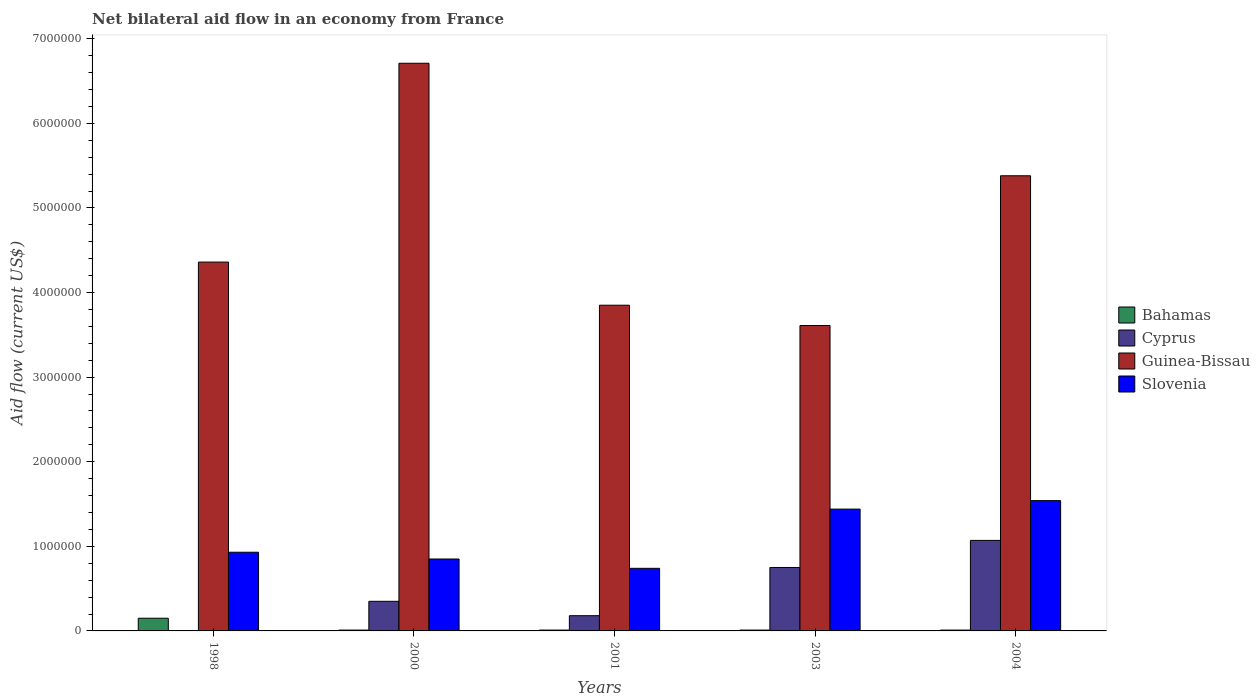How many different coloured bars are there?
Your answer should be very brief. 4. Are the number of bars per tick equal to the number of legend labels?
Provide a short and direct response. No. How many bars are there on the 3rd tick from the right?
Your response must be concise. 4. In how many cases, is the number of bars for a given year not equal to the number of legend labels?
Offer a very short reply. 1. What is the net bilateral aid flow in Slovenia in 2000?
Make the answer very short. 8.50e+05. Across all years, what is the maximum net bilateral aid flow in Cyprus?
Make the answer very short. 1.07e+06. What is the total net bilateral aid flow in Slovenia in the graph?
Make the answer very short. 5.50e+06. What is the difference between the net bilateral aid flow in Slovenia in 2000 and that in 2004?
Your response must be concise. -6.90e+05. What is the difference between the net bilateral aid flow in Cyprus in 2000 and the net bilateral aid flow in Guinea-Bissau in 1998?
Offer a terse response. -4.01e+06. What is the average net bilateral aid flow in Slovenia per year?
Give a very brief answer. 1.10e+06. In the year 2001, what is the difference between the net bilateral aid flow in Cyprus and net bilateral aid flow in Slovenia?
Make the answer very short. -5.60e+05. In how many years, is the net bilateral aid flow in Guinea-Bissau greater than 5800000 US$?
Make the answer very short. 1. What is the ratio of the net bilateral aid flow in Guinea-Bissau in 1998 to that in 2001?
Provide a succinct answer. 1.13. What is the difference between the highest and the second highest net bilateral aid flow in Cyprus?
Your answer should be very brief. 3.20e+05. What is the difference between the highest and the lowest net bilateral aid flow in Cyprus?
Keep it short and to the point. 1.07e+06. In how many years, is the net bilateral aid flow in Bahamas greater than the average net bilateral aid flow in Bahamas taken over all years?
Provide a short and direct response. 1. Is it the case that in every year, the sum of the net bilateral aid flow in Cyprus and net bilateral aid flow in Guinea-Bissau is greater than the sum of net bilateral aid flow in Slovenia and net bilateral aid flow in Bahamas?
Make the answer very short. Yes. Is it the case that in every year, the sum of the net bilateral aid flow in Slovenia and net bilateral aid flow in Guinea-Bissau is greater than the net bilateral aid flow in Cyprus?
Keep it short and to the point. Yes. Are all the bars in the graph horizontal?
Offer a very short reply. No. Does the graph contain any zero values?
Keep it short and to the point. Yes. Does the graph contain grids?
Offer a terse response. No. Where does the legend appear in the graph?
Your answer should be very brief. Center right. How many legend labels are there?
Give a very brief answer. 4. What is the title of the graph?
Your answer should be compact. Net bilateral aid flow in an economy from France. Does "Cuba" appear as one of the legend labels in the graph?
Your response must be concise. No. What is the label or title of the Y-axis?
Give a very brief answer. Aid flow (current US$). What is the Aid flow (current US$) in Bahamas in 1998?
Offer a very short reply. 1.50e+05. What is the Aid flow (current US$) of Cyprus in 1998?
Your answer should be compact. 0. What is the Aid flow (current US$) of Guinea-Bissau in 1998?
Offer a very short reply. 4.36e+06. What is the Aid flow (current US$) in Slovenia in 1998?
Make the answer very short. 9.30e+05. What is the Aid flow (current US$) of Bahamas in 2000?
Provide a succinct answer. 10000. What is the Aid flow (current US$) in Guinea-Bissau in 2000?
Offer a terse response. 6.71e+06. What is the Aid flow (current US$) of Slovenia in 2000?
Make the answer very short. 8.50e+05. What is the Aid flow (current US$) in Bahamas in 2001?
Keep it short and to the point. 10000. What is the Aid flow (current US$) in Cyprus in 2001?
Your answer should be compact. 1.80e+05. What is the Aid flow (current US$) of Guinea-Bissau in 2001?
Keep it short and to the point. 3.85e+06. What is the Aid flow (current US$) in Slovenia in 2001?
Offer a very short reply. 7.40e+05. What is the Aid flow (current US$) of Cyprus in 2003?
Keep it short and to the point. 7.50e+05. What is the Aid flow (current US$) in Guinea-Bissau in 2003?
Ensure brevity in your answer.  3.61e+06. What is the Aid flow (current US$) of Slovenia in 2003?
Provide a short and direct response. 1.44e+06. What is the Aid flow (current US$) in Cyprus in 2004?
Your response must be concise. 1.07e+06. What is the Aid flow (current US$) in Guinea-Bissau in 2004?
Make the answer very short. 5.38e+06. What is the Aid flow (current US$) in Slovenia in 2004?
Provide a short and direct response. 1.54e+06. Across all years, what is the maximum Aid flow (current US$) in Cyprus?
Make the answer very short. 1.07e+06. Across all years, what is the maximum Aid flow (current US$) of Guinea-Bissau?
Ensure brevity in your answer.  6.71e+06. Across all years, what is the maximum Aid flow (current US$) of Slovenia?
Your answer should be very brief. 1.54e+06. Across all years, what is the minimum Aid flow (current US$) in Cyprus?
Ensure brevity in your answer.  0. Across all years, what is the minimum Aid flow (current US$) of Guinea-Bissau?
Provide a short and direct response. 3.61e+06. Across all years, what is the minimum Aid flow (current US$) of Slovenia?
Your answer should be compact. 7.40e+05. What is the total Aid flow (current US$) of Cyprus in the graph?
Provide a succinct answer. 2.35e+06. What is the total Aid flow (current US$) in Guinea-Bissau in the graph?
Your answer should be compact. 2.39e+07. What is the total Aid flow (current US$) of Slovenia in the graph?
Offer a very short reply. 5.50e+06. What is the difference between the Aid flow (current US$) of Guinea-Bissau in 1998 and that in 2000?
Keep it short and to the point. -2.35e+06. What is the difference between the Aid flow (current US$) in Guinea-Bissau in 1998 and that in 2001?
Offer a very short reply. 5.10e+05. What is the difference between the Aid flow (current US$) of Guinea-Bissau in 1998 and that in 2003?
Provide a short and direct response. 7.50e+05. What is the difference between the Aid flow (current US$) in Slovenia in 1998 and that in 2003?
Keep it short and to the point. -5.10e+05. What is the difference between the Aid flow (current US$) in Guinea-Bissau in 1998 and that in 2004?
Give a very brief answer. -1.02e+06. What is the difference between the Aid flow (current US$) of Slovenia in 1998 and that in 2004?
Keep it short and to the point. -6.10e+05. What is the difference between the Aid flow (current US$) of Bahamas in 2000 and that in 2001?
Provide a succinct answer. 0. What is the difference between the Aid flow (current US$) of Guinea-Bissau in 2000 and that in 2001?
Make the answer very short. 2.86e+06. What is the difference between the Aid flow (current US$) in Bahamas in 2000 and that in 2003?
Provide a short and direct response. 0. What is the difference between the Aid flow (current US$) of Cyprus in 2000 and that in 2003?
Your response must be concise. -4.00e+05. What is the difference between the Aid flow (current US$) of Guinea-Bissau in 2000 and that in 2003?
Provide a succinct answer. 3.10e+06. What is the difference between the Aid flow (current US$) of Slovenia in 2000 and that in 2003?
Give a very brief answer. -5.90e+05. What is the difference between the Aid flow (current US$) of Cyprus in 2000 and that in 2004?
Provide a short and direct response. -7.20e+05. What is the difference between the Aid flow (current US$) in Guinea-Bissau in 2000 and that in 2004?
Ensure brevity in your answer.  1.33e+06. What is the difference between the Aid flow (current US$) of Slovenia in 2000 and that in 2004?
Your answer should be very brief. -6.90e+05. What is the difference between the Aid flow (current US$) in Cyprus in 2001 and that in 2003?
Provide a succinct answer. -5.70e+05. What is the difference between the Aid flow (current US$) in Slovenia in 2001 and that in 2003?
Make the answer very short. -7.00e+05. What is the difference between the Aid flow (current US$) of Cyprus in 2001 and that in 2004?
Keep it short and to the point. -8.90e+05. What is the difference between the Aid flow (current US$) of Guinea-Bissau in 2001 and that in 2004?
Your answer should be very brief. -1.53e+06. What is the difference between the Aid flow (current US$) in Slovenia in 2001 and that in 2004?
Offer a terse response. -8.00e+05. What is the difference between the Aid flow (current US$) of Bahamas in 2003 and that in 2004?
Your answer should be compact. 0. What is the difference between the Aid flow (current US$) of Cyprus in 2003 and that in 2004?
Your response must be concise. -3.20e+05. What is the difference between the Aid flow (current US$) in Guinea-Bissau in 2003 and that in 2004?
Ensure brevity in your answer.  -1.77e+06. What is the difference between the Aid flow (current US$) of Slovenia in 2003 and that in 2004?
Keep it short and to the point. -1.00e+05. What is the difference between the Aid flow (current US$) in Bahamas in 1998 and the Aid flow (current US$) in Guinea-Bissau in 2000?
Offer a very short reply. -6.56e+06. What is the difference between the Aid flow (current US$) in Bahamas in 1998 and the Aid flow (current US$) in Slovenia in 2000?
Offer a terse response. -7.00e+05. What is the difference between the Aid flow (current US$) in Guinea-Bissau in 1998 and the Aid flow (current US$) in Slovenia in 2000?
Your answer should be very brief. 3.51e+06. What is the difference between the Aid flow (current US$) in Bahamas in 1998 and the Aid flow (current US$) in Cyprus in 2001?
Offer a terse response. -3.00e+04. What is the difference between the Aid flow (current US$) of Bahamas in 1998 and the Aid flow (current US$) of Guinea-Bissau in 2001?
Your answer should be compact. -3.70e+06. What is the difference between the Aid flow (current US$) in Bahamas in 1998 and the Aid flow (current US$) in Slovenia in 2001?
Your answer should be compact. -5.90e+05. What is the difference between the Aid flow (current US$) of Guinea-Bissau in 1998 and the Aid flow (current US$) of Slovenia in 2001?
Ensure brevity in your answer.  3.62e+06. What is the difference between the Aid flow (current US$) of Bahamas in 1998 and the Aid flow (current US$) of Cyprus in 2003?
Offer a very short reply. -6.00e+05. What is the difference between the Aid flow (current US$) of Bahamas in 1998 and the Aid flow (current US$) of Guinea-Bissau in 2003?
Provide a succinct answer. -3.46e+06. What is the difference between the Aid flow (current US$) in Bahamas in 1998 and the Aid flow (current US$) in Slovenia in 2003?
Offer a very short reply. -1.29e+06. What is the difference between the Aid flow (current US$) of Guinea-Bissau in 1998 and the Aid flow (current US$) of Slovenia in 2003?
Offer a terse response. 2.92e+06. What is the difference between the Aid flow (current US$) in Bahamas in 1998 and the Aid flow (current US$) in Cyprus in 2004?
Provide a succinct answer. -9.20e+05. What is the difference between the Aid flow (current US$) of Bahamas in 1998 and the Aid flow (current US$) of Guinea-Bissau in 2004?
Provide a short and direct response. -5.23e+06. What is the difference between the Aid flow (current US$) of Bahamas in 1998 and the Aid flow (current US$) of Slovenia in 2004?
Offer a very short reply. -1.39e+06. What is the difference between the Aid flow (current US$) in Guinea-Bissau in 1998 and the Aid flow (current US$) in Slovenia in 2004?
Offer a terse response. 2.82e+06. What is the difference between the Aid flow (current US$) of Bahamas in 2000 and the Aid flow (current US$) of Guinea-Bissau in 2001?
Provide a short and direct response. -3.84e+06. What is the difference between the Aid flow (current US$) of Bahamas in 2000 and the Aid flow (current US$) of Slovenia in 2001?
Make the answer very short. -7.30e+05. What is the difference between the Aid flow (current US$) in Cyprus in 2000 and the Aid flow (current US$) in Guinea-Bissau in 2001?
Provide a succinct answer. -3.50e+06. What is the difference between the Aid flow (current US$) in Cyprus in 2000 and the Aid flow (current US$) in Slovenia in 2001?
Your answer should be very brief. -3.90e+05. What is the difference between the Aid flow (current US$) in Guinea-Bissau in 2000 and the Aid flow (current US$) in Slovenia in 2001?
Your answer should be very brief. 5.97e+06. What is the difference between the Aid flow (current US$) in Bahamas in 2000 and the Aid flow (current US$) in Cyprus in 2003?
Your answer should be very brief. -7.40e+05. What is the difference between the Aid flow (current US$) of Bahamas in 2000 and the Aid flow (current US$) of Guinea-Bissau in 2003?
Your answer should be compact. -3.60e+06. What is the difference between the Aid flow (current US$) of Bahamas in 2000 and the Aid flow (current US$) of Slovenia in 2003?
Offer a very short reply. -1.43e+06. What is the difference between the Aid flow (current US$) of Cyprus in 2000 and the Aid flow (current US$) of Guinea-Bissau in 2003?
Ensure brevity in your answer.  -3.26e+06. What is the difference between the Aid flow (current US$) in Cyprus in 2000 and the Aid flow (current US$) in Slovenia in 2003?
Ensure brevity in your answer.  -1.09e+06. What is the difference between the Aid flow (current US$) in Guinea-Bissau in 2000 and the Aid flow (current US$) in Slovenia in 2003?
Offer a terse response. 5.27e+06. What is the difference between the Aid flow (current US$) of Bahamas in 2000 and the Aid flow (current US$) of Cyprus in 2004?
Your answer should be compact. -1.06e+06. What is the difference between the Aid flow (current US$) in Bahamas in 2000 and the Aid flow (current US$) in Guinea-Bissau in 2004?
Ensure brevity in your answer.  -5.37e+06. What is the difference between the Aid flow (current US$) of Bahamas in 2000 and the Aid flow (current US$) of Slovenia in 2004?
Your answer should be very brief. -1.53e+06. What is the difference between the Aid flow (current US$) of Cyprus in 2000 and the Aid flow (current US$) of Guinea-Bissau in 2004?
Give a very brief answer. -5.03e+06. What is the difference between the Aid flow (current US$) of Cyprus in 2000 and the Aid flow (current US$) of Slovenia in 2004?
Give a very brief answer. -1.19e+06. What is the difference between the Aid flow (current US$) in Guinea-Bissau in 2000 and the Aid flow (current US$) in Slovenia in 2004?
Offer a terse response. 5.17e+06. What is the difference between the Aid flow (current US$) in Bahamas in 2001 and the Aid flow (current US$) in Cyprus in 2003?
Your answer should be compact. -7.40e+05. What is the difference between the Aid flow (current US$) of Bahamas in 2001 and the Aid flow (current US$) of Guinea-Bissau in 2003?
Provide a short and direct response. -3.60e+06. What is the difference between the Aid flow (current US$) of Bahamas in 2001 and the Aid flow (current US$) of Slovenia in 2003?
Your response must be concise. -1.43e+06. What is the difference between the Aid flow (current US$) in Cyprus in 2001 and the Aid flow (current US$) in Guinea-Bissau in 2003?
Your answer should be compact. -3.43e+06. What is the difference between the Aid flow (current US$) in Cyprus in 2001 and the Aid flow (current US$) in Slovenia in 2003?
Your answer should be very brief. -1.26e+06. What is the difference between the Aid flow (current US$) in Guinea-Bissau in 2001 and the Aid flow (current US$) in Slovenia in 2003?
Make the answer very short. 2.41e+06. What is the difference between the Aid flow (current US$) of Bahamas in 2001 and the Aid flow (current US$) of Cyprus in 2004?
Your answer should be compact. -1.06e+06. What is the difference between the Aid flow (current US$) of Bahamas in 2001 and the Aid flow (current US$) of Guinea-Bissau in 2004?
Make the answer very short. -5.37e+06. What is the difference between the Aid flow (current US$) of Bahamas in 2001 and the Aid flow (current US$) of Slovenia in 2004?
Give a very brief answer. -1.53e+06. What is the difference between the Aid flow (current US$) in Cyprus in 2001 and the Aid flow (current US$) in Guinea-Bissau in 2004?
Offer a very short reply. -5.20e+06. What is the difference between the Aid flow (current US$) in Cyprus in 2001 and the Aid flow (current US$) in Slovenia in 2004?
Offer a terse response. -1.36e+06. What is the difference between the Aid flow (current US$) in Guinea-Bissau in 2001 and the Aid flow (current US$) in Slovenia in 2004?
Make the answer very short. 2.31e+06. What is the difference between the Aid flow (current US$) in Bahamas in 2003 and the Aid flow (current US$) in Cyprus in 2004?
Offer a very short reply. -1.06e+06. What is the difference between the Aid flow (current US$) of Bahamas in 2003 and the Aid flow (current US$) of Guinea-Bissau in 2004?
Provide a succinct answer. -5.37e+06. What is the difference between the Aid flow (current US$) in Bahamas in 2003 and the Aid flow (current US$) in Slovenia in 2004?
Give a very brief answer. -1.53e+06. What is the difference between the Aid flow (current US$) in Cyprus in 2003 and the Aid flow (current US$) in Guinea-Bissau in 2004?
Your answer should be compact. -4.63e+06. What is the difference between the Aid flow (current US$) in Cyprus in 2003 and the Aid flow (current US$) in Slovenia in 2004?
Provide a short and direct response. -7.90e+05. What is the difference between the Aid flow (current US$) of Guinea-Bissau in 2003 and the Aid flow (current US$) of Slovenia in 2004?
Provide a short and direct response. 2.07e+06. What is the average Aid flow (current US$) in Bahamas per year?
Offer a terse response. 3.80e+04. What is the average Aid flow (current US$) of Guinea-Bissau per year?
Make the answer very short. 4.78e+06. What is the average Aid flow (current US$) in Slovenia per year?
Provide a short and direct response. 1.10e+06. In the year 1998, what is the difference between the Aid flow (current US$) in Bahamas and Aid flow (current US$) in Guinea-Bissau?
Your answer should be compact. -4.21e+06. In the year 1998, what is the difference between the Aid flow (current US$) of Bahamas and Aid flow (current US$) of Slovenia?
Offer a terse response. -7.80e+05. In the year 1998, what is the difference between the Aid flow (current US$) of Guinea-Bissau and Aid flow (current US$) of Slovenia?
Keep it short and to the point. 3.43e+06. In the year 2000, what is the difference between the Aid flow (current US$) of Bahamas and Aid flow (current US$) of Guinea-Bissau?
Offer a terse response. -6.70e+06. In the year 2000, what is the difference between the Aid flow (current US$) in Bahamas and Aid flow (current US$) in Slovenia?
Make the answer very short. -8.40e+05. In the year 2000, what is the difference between the Aid flow (current US$) of Cyprus and Aid flow (current US$) of Guinea-Bissau?
Your answer should be compact. -6.36e+06. In the year 2000, what is the difference between the Aid flow (current US$) in Cyprus and Aid flow (current US$) in Slovenia?
Ensure brevity in your answer.  -5.00e+05. In the year 2000, what is the difference between the Aid flow (current US$) in Guinea-Bissau and Aid flow (current US$) in Slovenia?
Provide a succinct answer. 5.86e+06. In the year 2001, what is the difference between the Aid flow (current US$) of Bahamas and Aid flow (current US$) of Cyprus?
Keep it short and to the point. -1.70e+05. In the year 2001, what is the difference between the Aid flow (current US$) in Bahamas and Aid flow (current US$) in Guinea-Bissau?
Keep it short and to the point. -3.84e+06. In the year 2001, what is the difference between the Aid flow (current US$) of Bahamas and Aid flow (current US$) of Slovenia?
Offer a terse response. -7.30e+05. In the year 2001, what is the difference between the Aid flow (current US$) of Cyprus and Aid flow (current US$) of Guinea-Bissau?
Your answer should be compact. -3.67e+06. In the year 2001, what is the difference between the Aid flow (current US$) of Cyprus and Aid flow (current US$) of Slovenia?
Provide a succinct answer. -5.60e+05. In the year 2001, what is the difference between the Aid flow (current US$) in Guinea-Bissau and Aid flow (current US$) in Slovenia?
Make the answer very short. 3.11e+06. In the year 2003, what is the difference between the Aid flow (current US$) of Bahamas and Aid flow (current US$) of Cyprus?
Provide a short and direct response. -7.40e+05. In the year 2003, what is the difference between the Aid flow (current US$) in Bahamas and Aid flow (current US$) in Guinea-Bissau?
Offer a very short reply. -3.60e+06. In the year 2003, what is the difference between the Aid flow (current US$) in Bahamas and Aid flow (current US$) in Slovenia?
Offer a terse response. -1.43e+06. In the year 2003, what is the difference between the Aid flow (current US$) in Cyprus and Aid flow (current US$) in Guinea-Bissau?
Your answer should be very brief. -2.86e+06. In the year 2003, what is the difference between the Aid flow (current US$) in Cyprus and Aid flow (current US$) in Slovenia?
Ensure brevity in your answer.  -6.90e+05. In the year 2003, what is the difference between the Aid flow (current US$) of Guinea-Bissau and Aid flow (current US$) of Slovenia?
Your answer should be compact. 2.17e+06. In the year 2004, what is the difference between the Aid flow (current US$) in Bahamas and Aid flow (current US$) in Cyprus?
Provide a short and direct response. -1.06e+06. In the year 2004, what is the difference between the Aid flow (current US$) in Bahamas and Aid flow (current US$) in Guinea-Bissau?
Provide a short and direct response. -5.37e+06. In the year 2004, what is the difference between the Aid flow (current US$) of Bahamas and Aid flow (current US$) of Slovenia?
Provide a succinct answer. -1.53e+06. In the year 2004, what is the difference between the Aid flow (current US$) in Cyprus and Aid flow (current US$) in Guinea-Bissau?
Keep it short and to the point. -4.31e+06. In the year 2004, what is the difference between the Aid flow (current US$) in Cyprus and Aid flow (current US$) in Slovenia?
Your answer should be compact. -4.70e+05. In the year 2004, what is the difference between the Aid flow (current US$) of Guinea-Bissau and Aid flow (current US$) of Slovenia?
Keep it short and to the point. 3.84e+06. What is the ratio of the Aid flow (current US$) of Bahamas in 1998 to that in 2000?
Your answer should be compact. 15. What is the ratio of the Aid flow (current US$) of Guinea-Bissau in 1998 to that in 2000?
Provide a succinct answer. 0.65. What is the ratio of the Aid flow (current US$) in Slovenia in 1998 to that in 2000?
Your answer should be very brief. 1.09. What is the ratio of the Aid flow (current US$) in Guinea-Bissau in 1998 to that in 2001?
Ensure brevity in your answer.  1.13. What is the ratio of the Aid flow (current US$) of Slovenia in 1998 to that in 2001?
Your response must be concise. 1.26. What is the ratio of the Aid flow (current US$) of Guinea-Bissau in 1998 to that in 2003?
Make the answer very short. 1.21. What is the ratio of the Aid flow (current US$) of Slovenia in 1998 to that in 2003?
Provide a succinct answer. 0.65. What is the ratio of the Aid flow (current US$) in Guinea-Bissau in 1998 to that in 2004?
Offer a terse response. 0.81. What is the ratio of the Aid flow (current US$) of Slovenia in 1998 to that in 2004?
Offer a very short reply. 0.6. What is the ratio of the Aid flow (current US$) of Bahamas in 2000 to that in 2001?
Provide a short and direct response. 1. What is the ratio of the Aid flow (current US$) of Cyprus in 2000 to that in 2001?
Give a very brief answer. 1.94. What is the ratio of the Aid flow (current US$) in Guinea-Bissau in 2000 to that in 2001?
Provide a short and direct response. 1.74. What is the ratio of the Aid flow (current US$) in Slovenia in 2000 to that in 2001?
Give a very brief answer. 1.15. What is the ratio of the Aid flow (current US$) in Bahamas in 2000 to that in 2003?
Provide a succinct answer. 1. What is the ratio of the Aid flow (current US$) of Cyprus in 2000 to that in 2003?
Provide a succinct answer. 0.47. What is the ratio of the Aid flow (current US$) in Guinea-Bissau in 2000 to that in 2003?
Your answer should be compact. 1.86. What is the ratio of the Aid flow (current US$) in Slovenia in 2000 to that in 2003?
Ensure brevity in your answer.  0.59. What is the ratio of the Aid flow (current US$) of Cyprus in 2000 to that in 2004?
Give a very brief answer. 0.33. What is the ratio of the Aid flow (current US$) of Guinea-Bissau in 2000 to that in 2004?
Make the answer very short. 1.25. What is the ratio of the Aid flow (current US$) of Slovenia in 2000 to that in 2004?
Your answer should be very brief. 0.55. What is the ratio of the Aid flow (current US$) in Cyprus in 2001 to that in 2003?
Your answer should be compact. 0.24. What is the ratio of the Aid flow (current US$) in Guinea-Bissau in 2001 to that in 2003?
Provide a succinct answer. 1.07. What is the ratio of the Aid flow (current US$) of Slovenia in 2001 to that in 2003?
Give a very brief answer. 0.51. What is the ratio of the Aid flow (current US$) of Bahamas in 2001 to that in 2004?
Make the answer very short. 1. What is the ratio of the Aid flow (current US$) in Cyprus in 2001 to that in 2004?
Give a very brief answer. 0.17. What is the ratio of the Aid flow (current US$) of Guinea-Bissau in 2001 to that in 2004?
Your answer should be compact. 0.72. What is the ratio of the Aid flow (current US$) of Slovenia in 2001 to that in 2004?
Make the answer very short. 0.48. What is the ratio of the Aid flow (current US$) in Bahamas in 2003 to that in 2004?
Your answer should be compact. 1. What is the ratio of the Aid flow (current US$) of Cyprus in 2003 to that in 2004?
Offer a terse response. 0.7. What is the ratio of the Aid flow (current US$) in Guinea-Bissau in 2003 to that in 2004?
Provide a short and direct response. 0.67. What is the ratio of the Aid flow (current US$) of Slovenia in 2003 to that in 2004?
Provide a succinct answer. 0.94. What is the difference between the highest and the second highest Aid flow (current US$) in Bahamas?
Provide a short and direct response. 1.40e+05. What is the difference between the highest and the second highest Aid flow (current US$) in Cyprus?
Your answer should be compact. 3.20e+05. What is the difference between the highest and the second highest Aid flow (current US$) in Guinea-Bissau?
Offer a very short reply. 1.33e+06. What is the difference between the highest and the second highest Aid flow (current US$) in Slovenia?
Your response must be concise. 1.00e+05. What is the difference between the highest and the lowest Aid flow (current US$) in Cyprus?
Provide a succinct answer. 1.07e+06. What is the difference between the highest and the lowest Aid flow (current US$) in Guinea-Bissau?
Provide a succinct answer. 3.10e+06. 